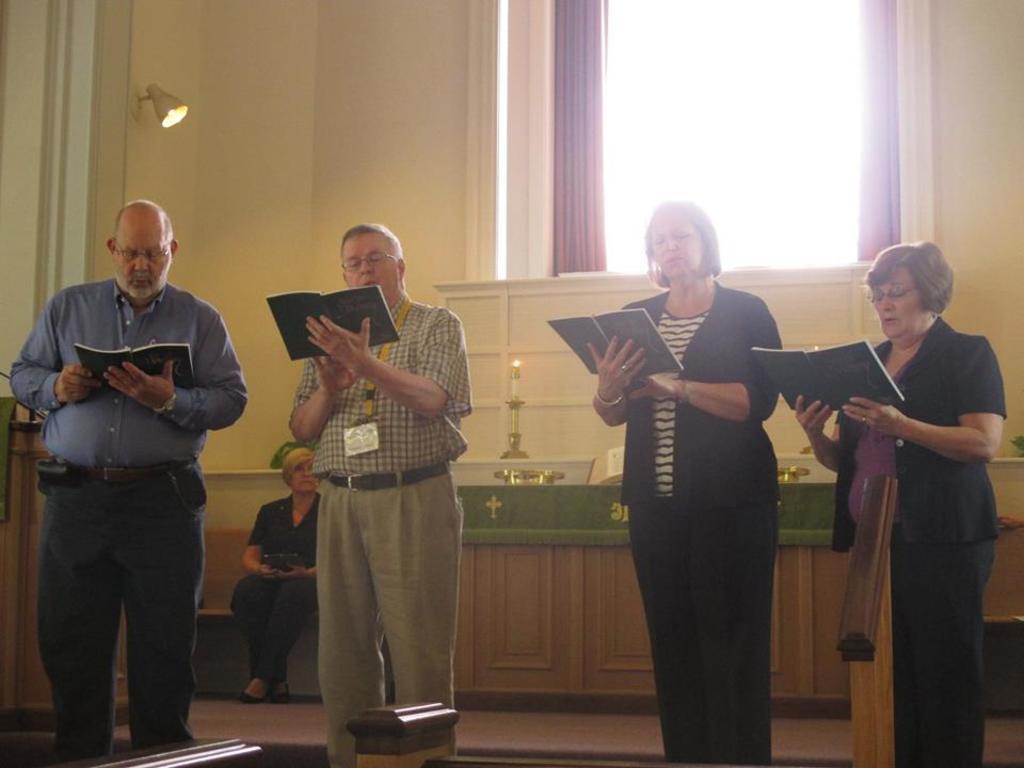Describe this image in one or two sentences. In this image, I can see four persons standing and holding the books. In the background, I can see a table with a candle and few other objects. There is a person sitting on the bench. At the top of the image, I can see a window and the curtains hanging. On the left side of the image, I can see a lamp attached to the wall. 